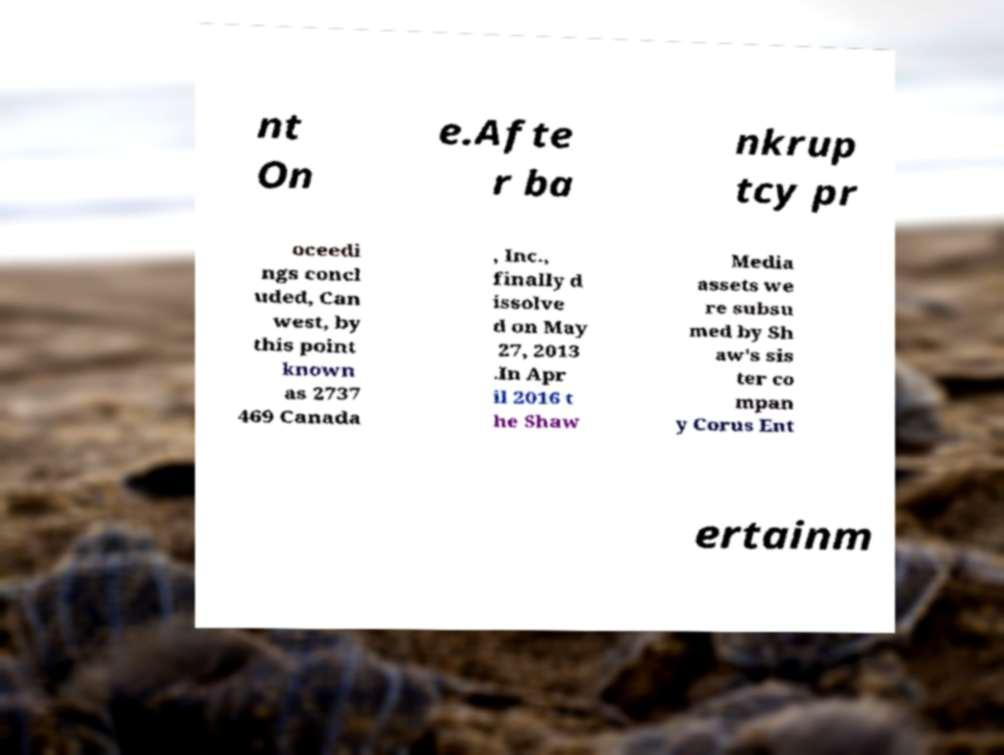Could you assist in decoding the text presented in this image and type it out clearly? nt On e.Afte r ba nkrup tcy pr oceedi ngs concl uded, Can west, by this point known as 2737 469 Canada , Inc., finally d issolve d on May 27, 2013 .In Apr il 2016 t he Shaw Media assets we re subsu med by Sh aw's sis ter co mpan y Corus Ent ertainm 